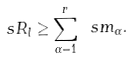Convert formula to latex. <formula><loc_0><loc_0><loc_500><loc_500>\ s R _ { l } \geq \sum _ { \alpha = 1 } ^ { r } \ s m _ { \alpha } .</formula> 